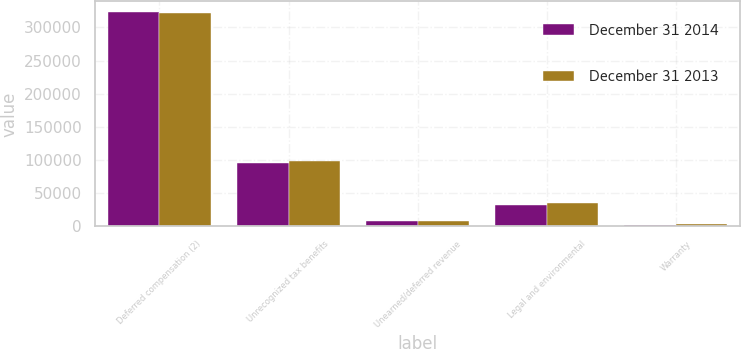<chart> <loc_0><loc_0><loc_500><loc_500><stacked_bar_chart><ecel><fcel>Deferred compensation (2)<fcel>Unrecognized tax benefits<fcel>Unearned/deferred revenue<fcel>Legal and environmental<fcel>Warranty<nl><fcel>December 31 2014<fcel>323105<fcel>94875<fcel>8599<fcel>31841<fcel>2684<nl><fcel>December 31 2013<fcel>321736<fcel>97920<fcel>7751<fcel>35145<fcel>3100<nl></chart> 